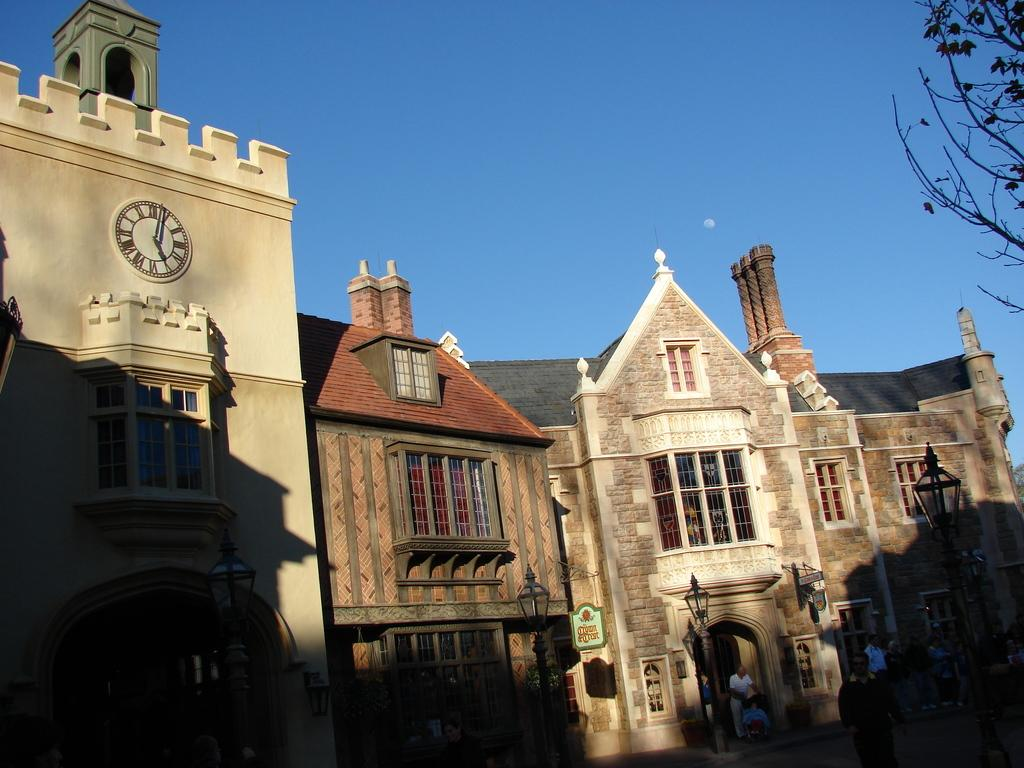What type of structures can be seen in the image? There are buildings in the image. What architectural features are present in the image? There are walls and windows in the image. What type of lighting is present in the image? There are streetlights in the image. What time-related object is visible in the image? There is a clock in the image. What type of signage is present in the image? There are boards in the image. Are there any living beings in the image? Yes, there are people in the image. What can be seen in the background of the image? The sky is visible in the background of the image. What type of vegetation is on the right side of the image? There are trees on the right side of the image. Can you see any grass growing in the image? There is no grass visible in the image. Is there a maid cleaning the floors in the image? There is no maid present in the image. How many ants can be seen crawling on the clock in the image? There are no ants visible in the image. 